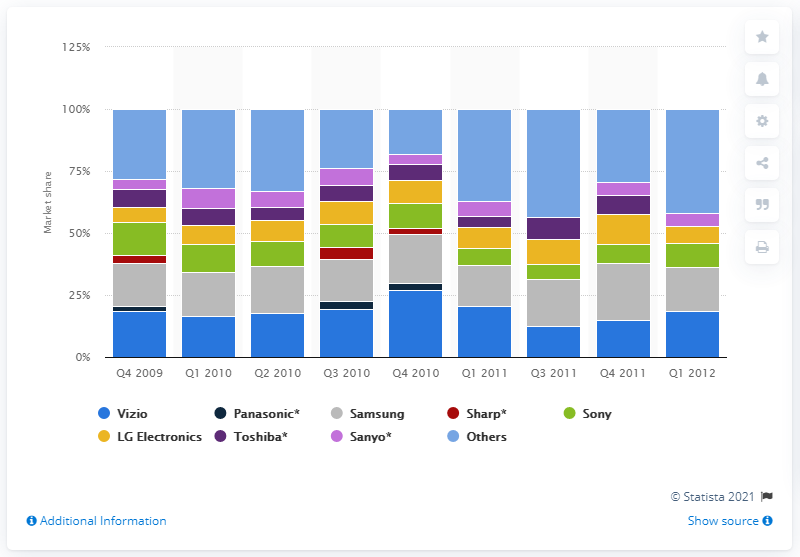Draw attention to some important aspects in this diagram. In the fourth quarter of 2009, Sharp's market share was 3.2%. 